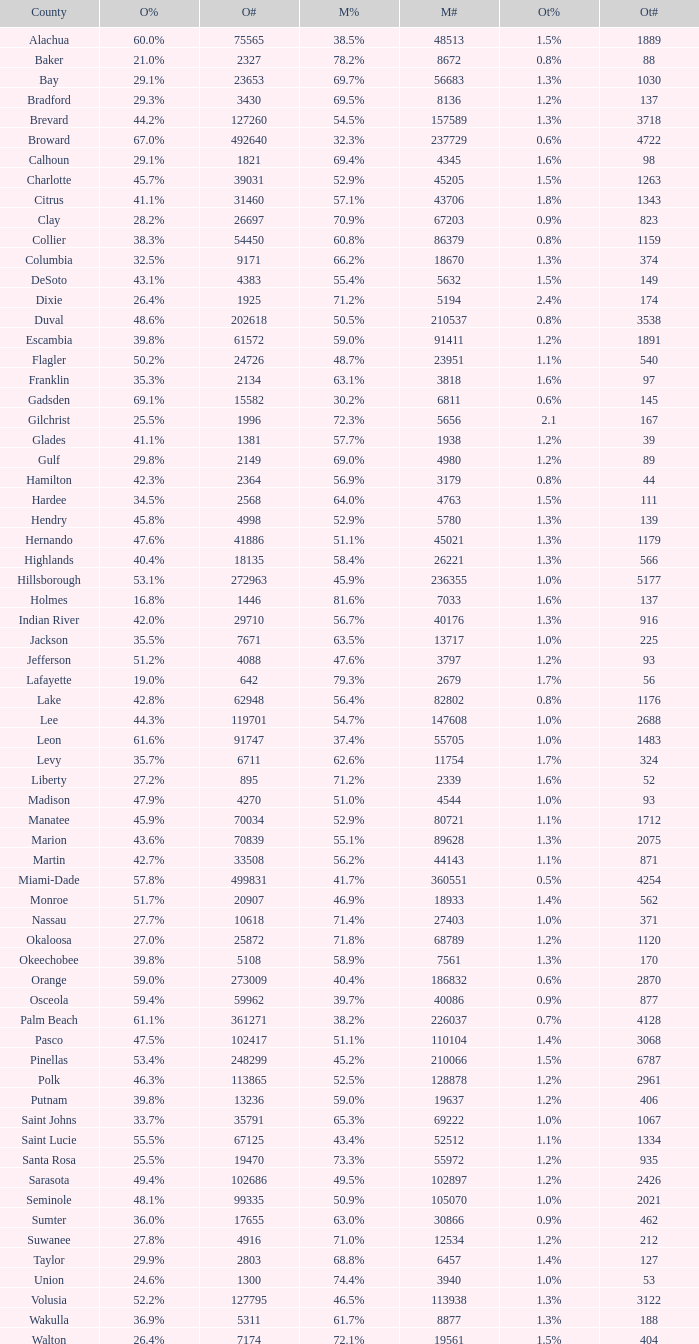Parse the full table. {'header': ['County', 'O%', 'O#', 'M%', 'M#', 'Ot%', 'Ot#'], 'rows': [['Alachua', '60.0%', '75565', '38.5%', '48513', '1.5%', '1889'], ['Baker', '21.0%', '2327', '78.2%', '8672', '0.8%', '88'], ['Bay', '29.1%', '23653', '69.7%', '56683', '1.3%', '1030'], ['Bradford', '29.3%', '3430', '69.5%', '8136', '1.2%', '137'], ['Brevard', '44.2%', '127260', '54.5%', '157589', '1.3%', '3718'], ['Broward', '67.0%', '492640', '32.3%', '237729', '0.6%', '4722'], ['Calhoun', '29.1%', '1821', '69.4%', '4345', '1.6%', '98'], ['Charlotte', '45.7%', '39031', '52.9%', '45205', '1.5%', '1263'], ['Citrus', '41.1%', '31460', '57.1%', '43706', '1.8%', '1343'], ['Clay', '28.2%', '26697', '70.9%', '67203', '0.9%', '823'], ['Collier', '38.3%', '54450', '60.8%', '86379', '0.8%', '1159'], ['Columbia', '32.5%', '9171', '66.2%', '18670', '1.3%', '374'], ['DeSoto', '43.1%', '4383', '55.4%', '5632', '1.5%', '149'], ['Dixie', '26.4%', '1925', '71.2%', '5194', '2.4%', '174'], ['Duval', '48.6%', '202618', '50.5%', '210537', '0.8%', '3538'], ['Escambia', '39.8%', '61572', '59.0%', '91411', '1.2%', '1891'], ['Flagler', '50.2%', '24726', '48.7%', '23951', '1.1%', '540'], ['Franklin', '35.3%', '2134', '63.1%', '3818', '1.6%', '97'], ['Gadsden', '69.1%', '15582', '30.2%', '6811', '0.6%', '145'], ['Gilchrist', '25.5%', '1996', '72.3%', '5656', '2.1', '167'], ['Glades', '41.1%', '1381', '57.7%', '1938', '1.2%', '39'], ['Gulf', '29.8%', '2149', '69.0%', '4980', '1.2%', '89'], ['Hamilton', '42.3%', '2364', '56.9%', '3179', '0.8%', '44'], ['Hardee', '34.5%', '2568', '64.0%', '4763', '1.5%', '111'], ['Hendry', '45.8%', '4998', '52.9%', '5780', '1.3%', '139'], ['Hernando', '47.6%', '41886', '51.1%', '45021', '1.3%', '1179'], ['Highlands', '40.4%', '18135', '58.4%', '26221', '1.3%', '566'], ['Hillsborough', '53.1%', '272963', '45.9%', '236355', '1.0%', '5177'], ['Holmes', '16.8%', '1446', '81.6%', '7033', '1.6%', '137'], ['Indian River', '42.0%', '29710', '56.7%', '40176', '1.3%', '916'], ['Jackson', '35.5%', '7671', '63.5%', '13717', '1.0%', '225'], ['Jefferson', '51.2%', '4088', '47.6%', '3797', '1.2%', '93'], ['Lafayette', '19.0%', '642', '79.3%', '2679', '1.7%', '56'], ['Lake', '42.8%', '62948', '56.4%', '82802', '0.8%', '1176'], ['Lee', '44.3%', '119701', '54.7%', '147608', '1.0%', '2688'], ['Leon', '61.6%', '91747', '37.4%', '55705', '1.0%', '1483'], ['Levy', '35.7%', '6711', '62.6%', '11754', '1.7%', '324'], ['Liberty', '27.2%', '895', '71.2%', '2339', '1.6%', '52'], ['Madison', '47.9%', '4270', '51.0%', '4544', '1.0%', '93'], ['Manatee', '45.9%', '70034', '52.9%', '80721', '1.1%', '1712'], ['Marion', '43.6%', '70839', '55.1%', '89628', '1.3%', '2075'], ['Martin', '42.7%', '33508', '56.2%', '44143', '1.1%', '871'], ['Miami-Dade', '57.8%', '499831', '41.7%', '360551', '0.5%', '4254'], ['Monroe', '51.7%', '20907', '46.9%', '18933', '1.4%', '562'], ['Nassau', '27.7%', '10618', '71.4%', '27403', '1.0%', '371'], ['Okaloosa', '27.0%', '25872', '71.8%', '68789', '1.2%', '1120'], ['Okeechobee', '39.8%', '5108', '58.9%', '7561', '1.3%', '170'], ['Orange', '59.0%', '273009', '40.4%', '186832', '0.6%', '2870'], ['Osceola', '59.4%', '59962', '39.7%', '40086', '0.9%', '877'], ['Palm Beach', '61.1%', '361271', '38.2%', '226037', '0.7%', '4128'], ['Pasco', '47.5%', '102417', '51.1%', '110104', '1.4%', '3068'], ['Pinellas', '53.4%', '248299', '45.2%', '210066', '1.5%', '6787'], ['Polk', '46.3%', '113865', '52.5%', '128878', '1.2%', '2961'], ['Putnam', '39.8%', '13236', '59.0%', '19637', '1.2%', '406'], ['Saint Johns', '33.7%', '35791', '65.3%', '69222', '1.0%', '1067'], ['Saint Lucie', '55.5%', '67125', '43.4%', '52512', '1.1%', '1334'], ['Santa Rosa', '25.5%', '19470', '73.3%', '55972', '1.2%', '935'], ['Sarasota', '49.4%', '102686', '49.5%', '102897', '1.2%', '2426'], ['Seminole', '48.1%', '99335', '50.9%', '105070', '1.0%', '2021'], ['Sumter', '36.0%', '17655', '63.0%', '30866', '0.9%', '462'], ['Suwanee', '27.8%', '4916', '71.0%', '12534', '1.2%', '212'], ['Taylor', '29.9%', '2803', '68.8%', '6457', '1.4%', '127'], ['Union', '24.6%', '1300', '74.4%', '3940', '1.0%', '53'], ['Volusia', '52.2%', '127795', '46.5%', '113938', '1.3%', '3122'], ['Wakulla', '36.9%', '5311', '61.7%', '8877', '1.3%', '188'], ['Walton', '26.4%', '7174', '72.1%', '19561', '1.5%', '404']]} What was the number of others votes in Columbia county? 374.0. 